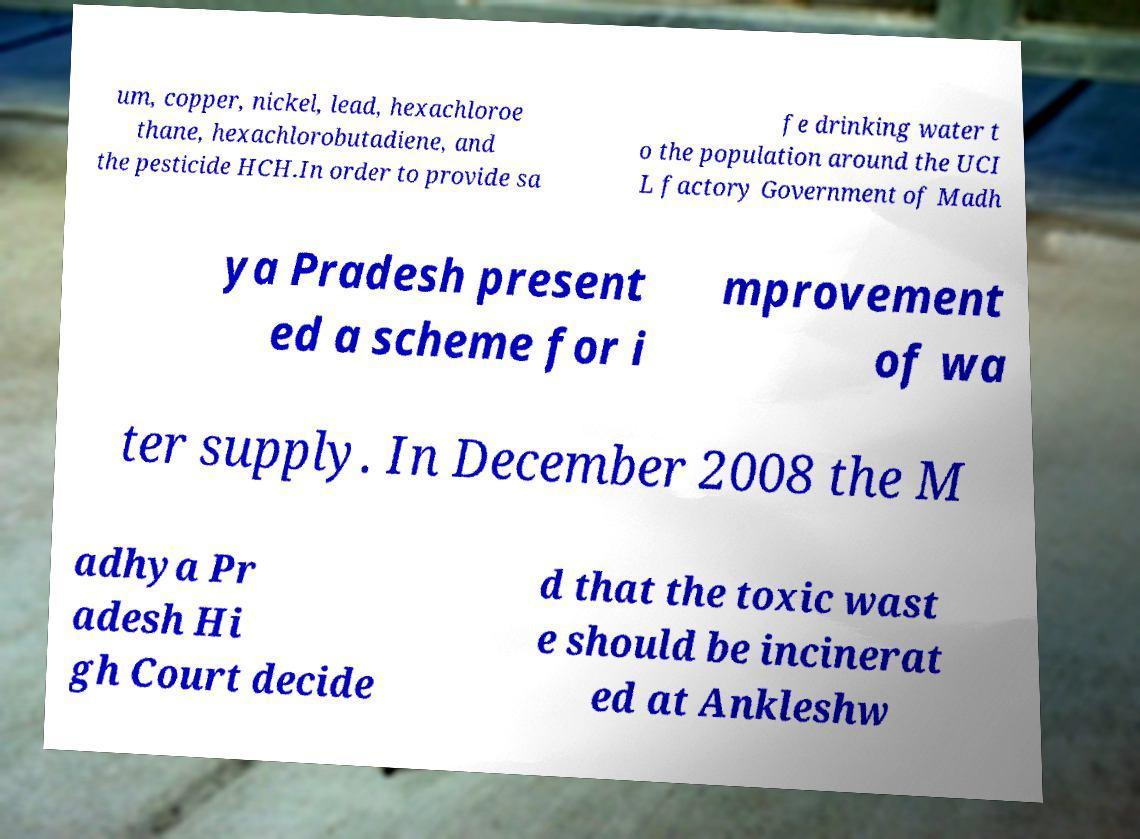Please identify and transcribe the text found in this image. um, copper, nickel, lead, hexachloroe thane, hexachlorobutadiene, and the pesticide HCH.In order to provide sa fe drinking water t o the population around the UCI L factory Government of Madh ya Pradesh present ed a scheme for i mprovement of wa ter supply. In December 2008 the M adhya Pr adesh Hi gh Court decide d that the toxic wast e should be incinerat ed at Ankleshw 